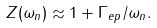Convert formula to latex. <formula><loc_0><loc_0><loc_500><loc_500>Z ( \omega _ { n } ) \approx 1 + \Gamma _ { e p } / \omega _ { n } .</formula> 